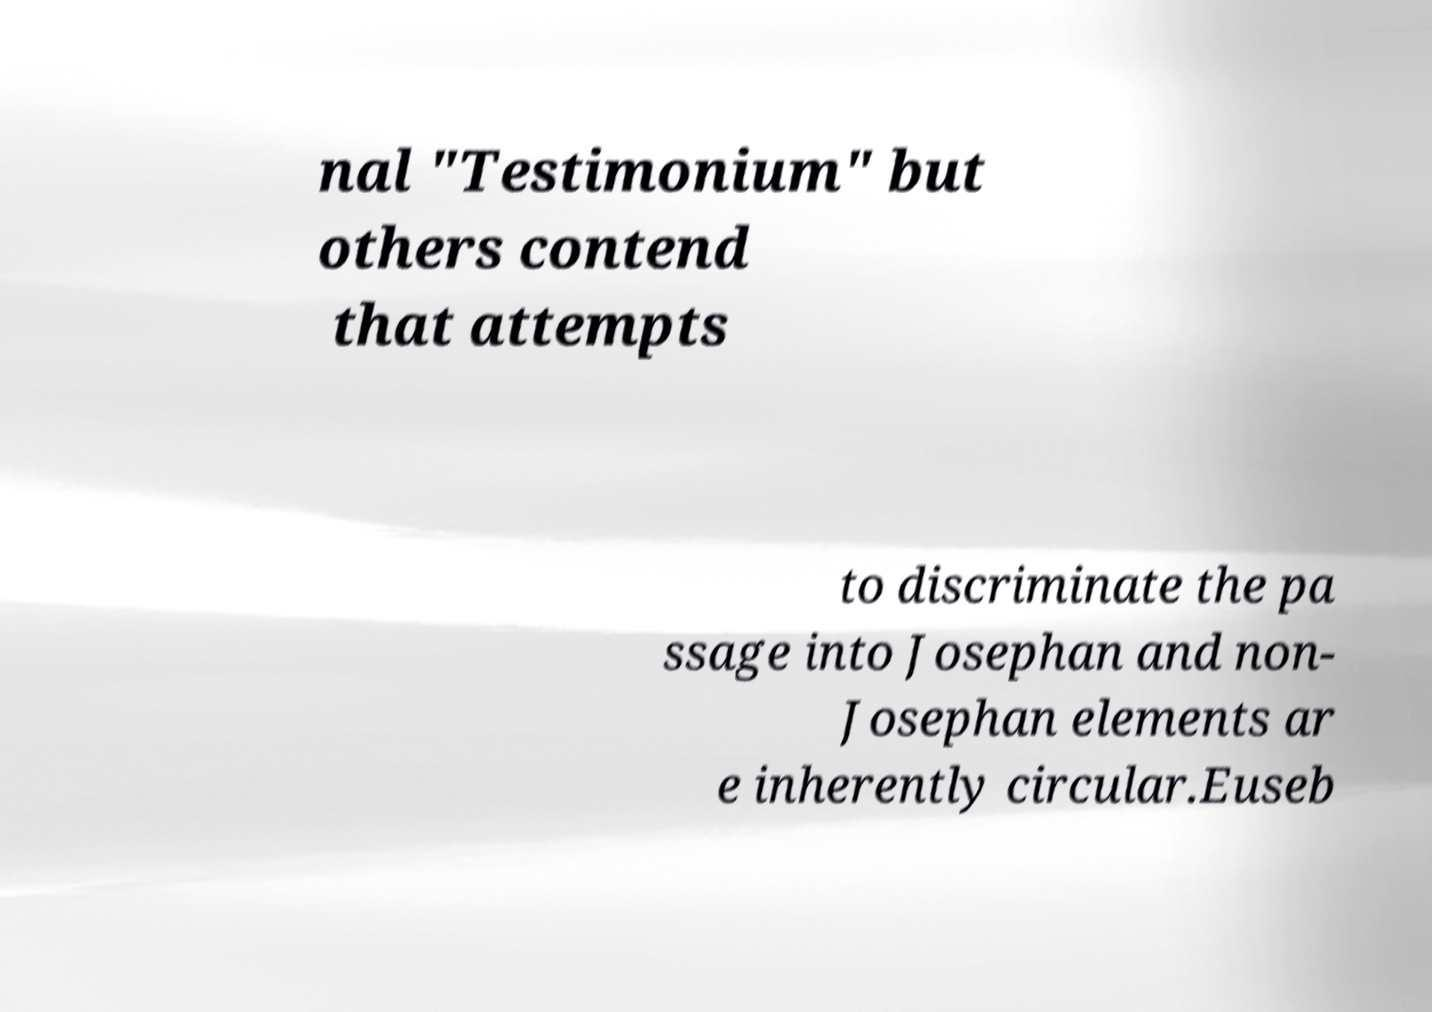Can you read and provide the text displayed in the image?This photo seems to have some interesting text. Can you extract and type it out for me? nal "Testimonium" but others contend that attempts to discriminate the pa ssage into Josephan and non- Josephan elements ar e inherently circular.Euseb 